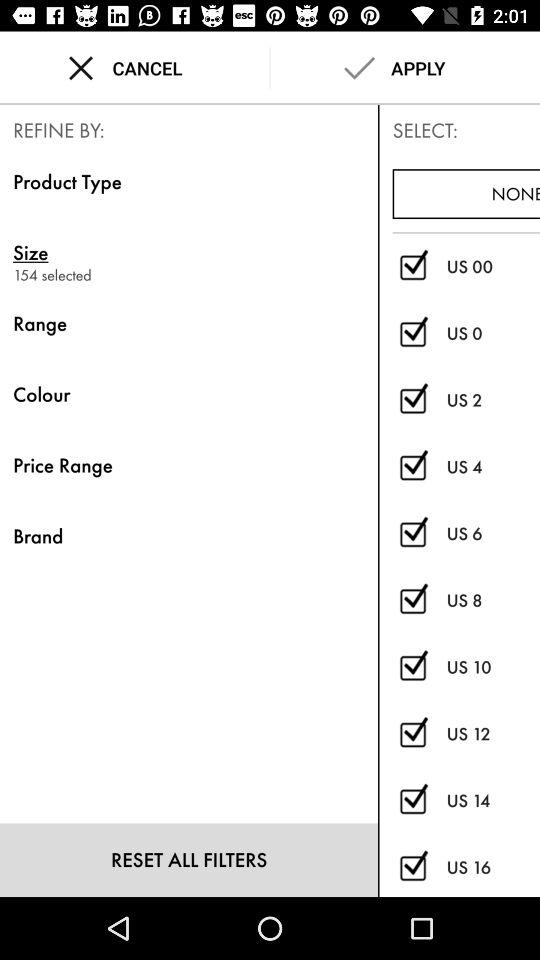How many sizes are selected? The selected sizes are 154. 